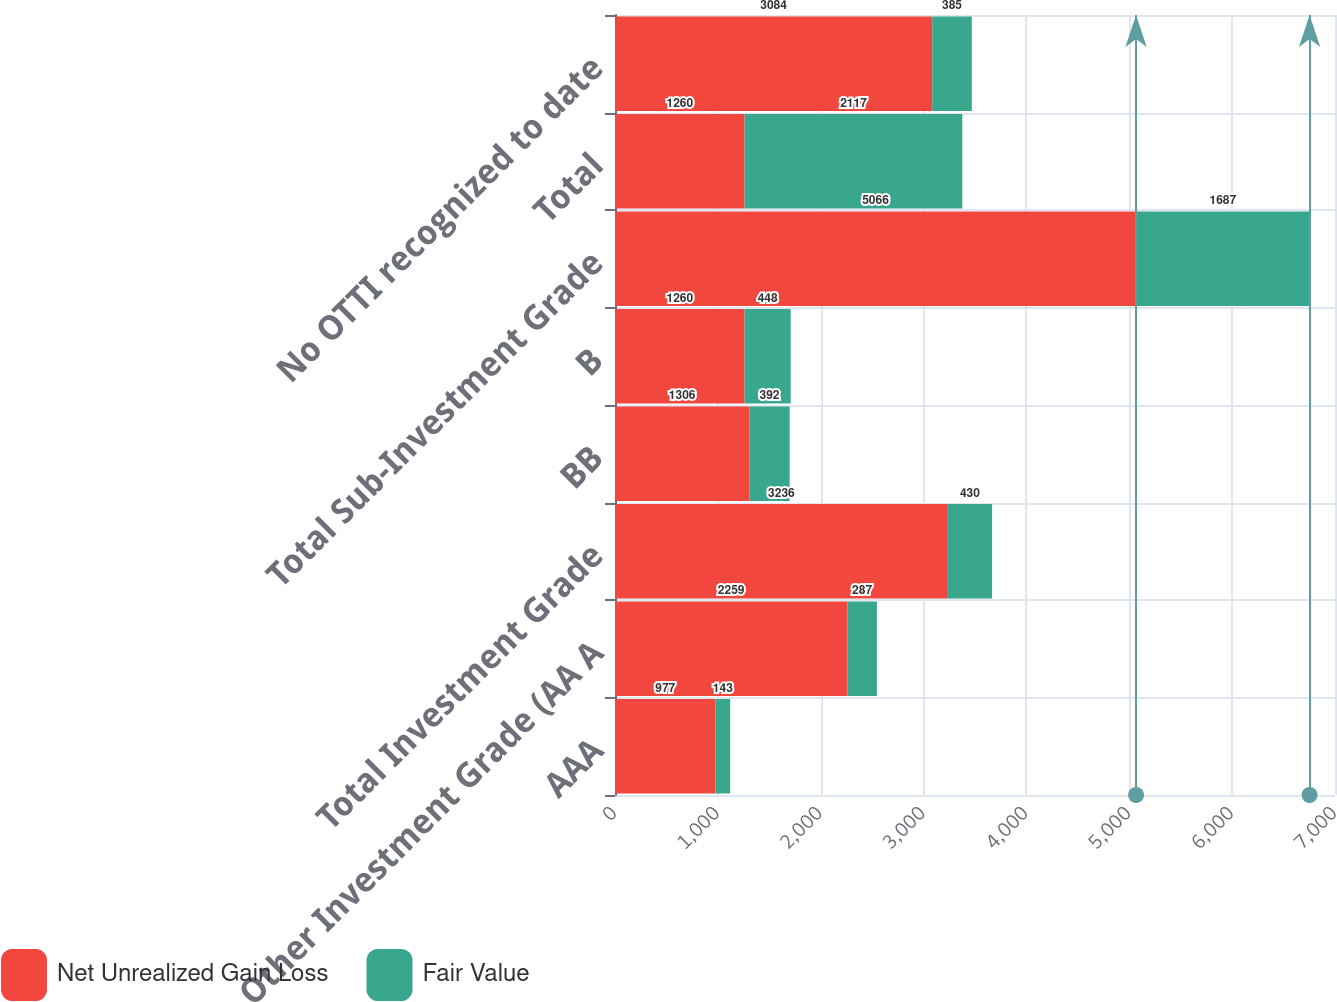Convert chart. <chart><loc_0><loc_0><loc_500><loc_500><stacked_bar_chart><ecel><fcel>AAA<fcel>Other Investment Grade (AA A<fcel>Total Investment Grade<fcel>BB<fcel>B<fcel>Total Sub-Investment Grade<fcel>Total<fcel>No OTTI recognized to date<nl><fcel>Net Unrealized Gain Loss<fcel>977<fcel>2259<fcel>3236<fcel>1306<fcel>1260<fcel>5066<fcel>1260<fcel>3084<nl><fcel>Fair Value<fcel>143<fcel>287<fcel>430<fcel>392<fcel>448<fcel>1687<fcel>2117<fcel>385<nl></chart> 